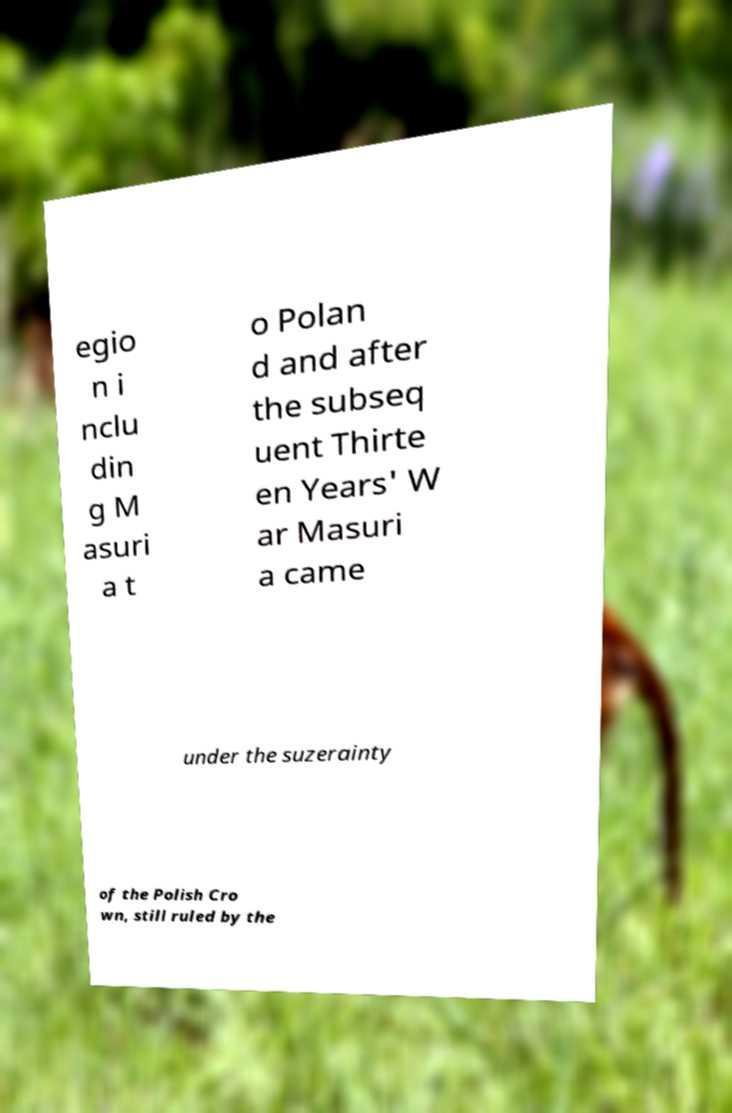I need the written content from this picture converted into text. Can you do that? egio n i nclu din g M asuri a t o Polan d and after the subseq uent Thirte en Years' W ar Masuri a came under the suzerainty of the Polish Cro wn, still ruled by the 